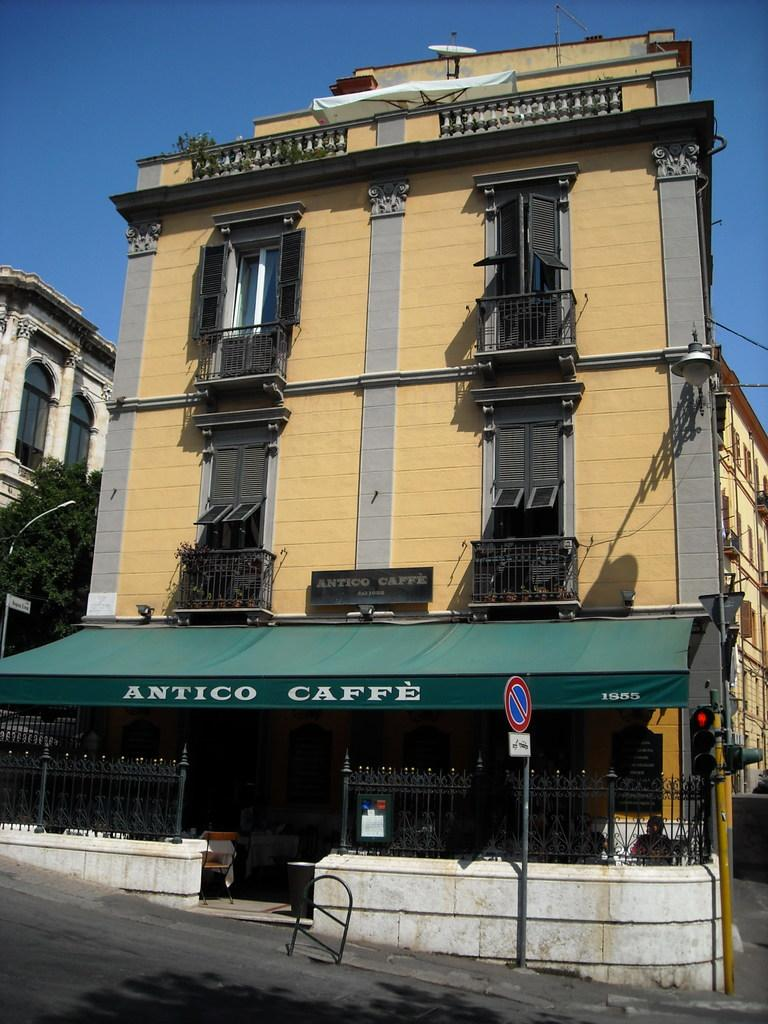What type of structures can be seen in the image? There are buildings in the image. What is the purpose of the sign board in the image? The purpose of the sign board in the image is not specified, but it may provide information or directions. What traffic control devices are present in the image? There are traffic lights in the image. Can you describe any other objects in the image? There are other objects in the image, but their specific details are not mentioned in the provided facts. What can be seen in the background of the image? The sky is visible in the background of the image. Is the baseball game in the image quiet? There is no mention of a baseball game or any noise level in the image, so it cannot be determined if the game is quiet or not. 